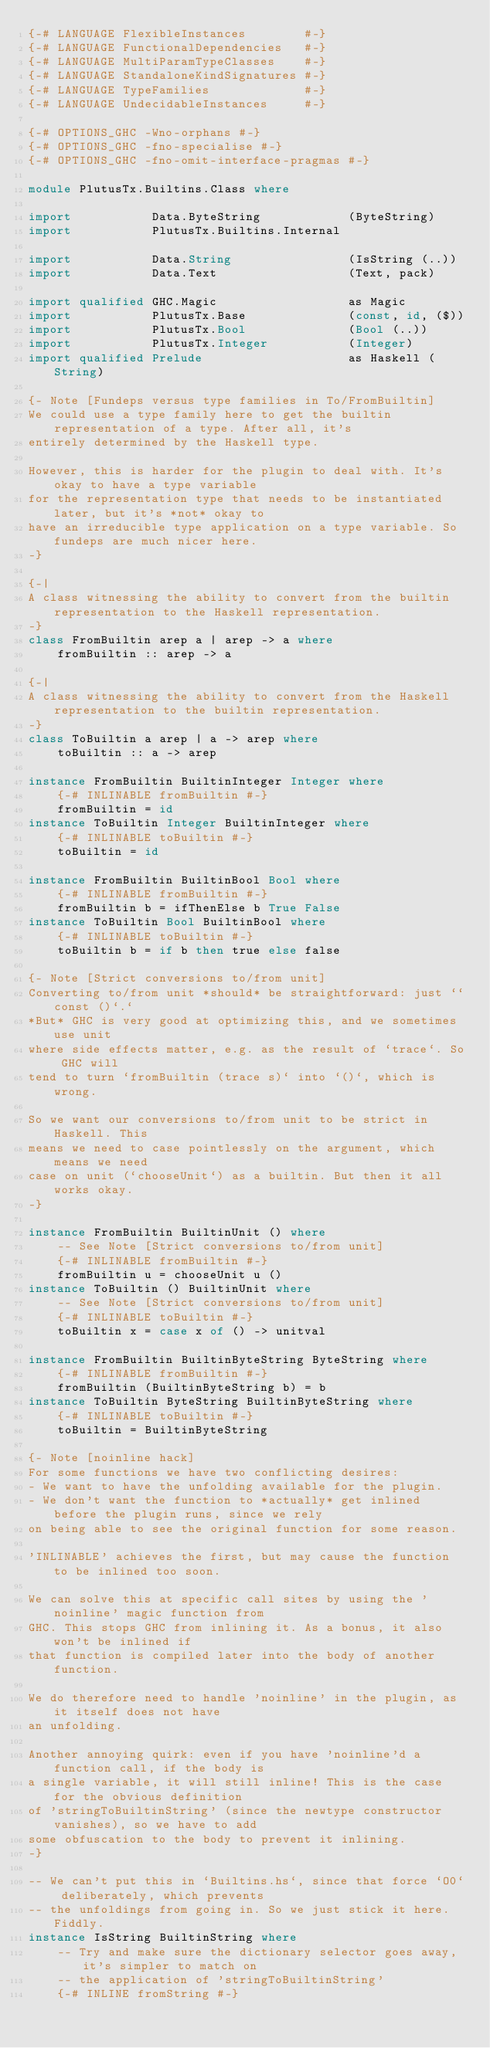Convert code to text. <code><loc_0><loc_0><loc_500><loc_500><_Haskell_>{-# LANGUAGE FlexibleInstances        #-}
{-# LANGUAGE FunctionalDependencies   #-}
{-# LANGUAGE MultiParamTypeClasses    #-}
{-# LANGUAGE StandaloneKindSignatures #-}
{-# LANGUAGE TypeFamilies             #-}
{-# LANGUAGE UndecidableInstances     #-}

{-# OPTIONS_GHC -Wno-orphans #-}
{-# OPTIONS_GHC -fno-specialise #-}
{-# OPTIONS_GHC -fno-omit-interface-pragmas #-}

module PlutusTx.Builtins.Class where

import           Data.ByteString            (ByteString)
import           PlutusTx.Builtins.Internal

import           Data.String                (IsString (..))
import           Data.Text                  (Text, pack)

import qualified GHC.Magic                  as Magic
import           PlutusTx.Base              (const, id, ($))
import           PlutusTx.Bool              (Bool (..))
import           PlutusTx.Integer           (Integer)
import qualified Prelude                    as Haskell (String)

{- Note [Fundeps versus type families in To/FromBuiltin]
We could use a type family here to get the builtin representation of a type. After all, it's
entirely determined by the Haskell type.

However, this is harder for the plugin to deal with. It's okay to have a type variable
for the representation type that needs to be instantiated later, but it's *not* okay to
have an irreducible type application on a type variable. So fundeps are much nicer here.
-}

{-|
A class witnessing the ability to convert from the builtin representation to the Haskell representation.
-}
class FromBuiltin arep a | arep -> a where
    fromBuiltin :: arep -> a

{-|
A class witnessing the ability to convert from the Haskell representation to the builtin representation.
-}
class ToBuiltin a arep | a -> arep where
    toBuiltin :: a -> arep

instance FromBuiltin BuiltinInteger Integer where
    {-# INLINABLE fromBuiltin #-}
    fromBuiltin = id
instance ToBuiltin Integer BuiltinInteger where
    {-# INLINABLE toBuiltin #-}
    toBuiltin = id

instance FromBuiltin BuiltinBool Bool where
    {-# INLINABLE fromBuiltin #-}
    fromBuiltin b = ifThenElse b True False
instance ToBuiltin Bool BuiltinBool where
    {-# INLINABLE toBuiltin #-}
    toBuiltin b = if b then true else false

{- Note [Strict conversions to/from unit]
Converting to/from unit *should* be straightforward: just ``const ()`.`
*But* GHC is very good at optimizing this, and we sometimes use unit
where side effects matter, e.g. as the result of `trace`. So GHC will
tend to turn `fromBuiltin (trace s)` into `()`, which is wrong.

So we want our conversions to/from unit to be strict in Haskell. This
means we need to case pointlessly on the argument, which means we need
case on unit (`chooseUnit`) as a builtin. But then it all works okay.
-}

instance FromBuiltin BuiltinUnit () where
    -- See Note [Strict conversions to/from unit]
    {-# INLINABLE fromBuiltin #-}
    fromBuiltin u = chooseUnit u ()
instance ToBuiltin () BuiltinUnit where
    -- See Note [Strict conversions to/from unit]
    {-# INLINABLE toBuiltin #-}
    toBuiltin x = case x of () -> unitval

instance FromBuiltin BuiltinByteString ByteString where
    {-# INLINABLE fromBuiltin #-}
    fromBuiltin (BuiltinByteString b) = b
instance ToBuiltin ByteString BuiltinByteString where
    {-# INLINABLE toBuiltin #-}
    toBuiltin = BuiltinByteString

{- Note [noinline hack]
For some functions we have two conflicting desires:
- We want to have the unfolding available for the plugin.
- We don't want the function to *actually* get inlined before the plugin runs, since we rely
on being able to see the original function for some reason.

'INLINABLE' achieves the first, but may cause the function to be inlined too soon.

We can solve this at specific call sites by using the 'noinline' magic function from
GHC. This stops GHC from inlining it. As a bonus, it also won't be inlined if
that function is compiled later into the body of another function.

We do therefore need to handle 'noinline' in the plugin, as it itself does not have
an unfolding.

Another annoying quirk: even if you have 'noinline'd a function call, if the body is
a single variable, it will still inline! This is the case for the obvious definition
of 'stringToBuiltinString' (since the newtype constructor vanishes), so we have to add
some obfuscation to the body to prevent it inlining.
-}

-- We can't put this in `Builtins.hs`, since that force `O0` deliberately, which prevents
-- the unfoldings from going in. So we just stick it here. Fiddly.
instance IsString BuiltinString where
    -- Try and make sure the dictionary selector goes away, it's simpler to match on
    -- the application of 'stringToBuiltinString'
    {-# INLINE fromString #-}</code> 